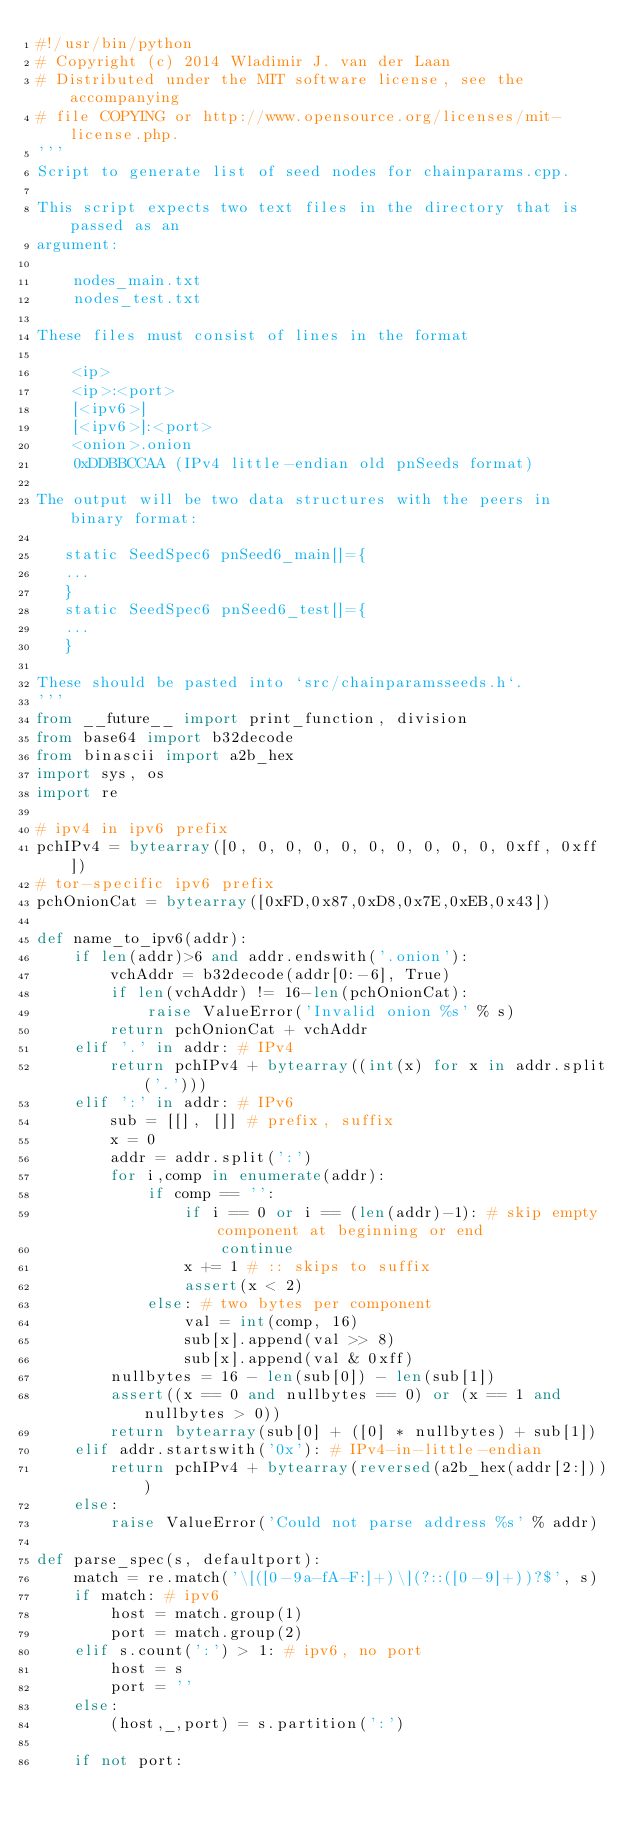Convert code to text. <code><loc_0><loc_0><loc_500><loc_500><_Python_>#!/usr/bin/python
# Copyright (c) 2014 Wladimir J. van der Laan
# Distributed under the MIT software license, see the accompanying
# file COPYING or http://www.opensource.org/licenses/mit-license.php.
'''
Script to generate list of seed nodes for chainparams.cpp.

This script expects two text files in the directory that is passed as an
argument:

    nodes_main.txt
    nodes_test.txt

These files must consist of lines in the format 

    <ip>
    <ip>:<port>
    [<ipv6>]
    [<ipv6>]:<port>
    <onion>.onion
    0xDDBBCCAA (IPv4 little-endian old pnSeeds format)

The output will be two data structures with the peers in binary format:

   static SeedSpec6 pnSeed6_main[]={
   ...
   }
   static SeedSpec6 pnSeed6_test[]={
   ...
   }

These should be pasted into `src/chainparamsseeds.h`.
'''
from __future__ import print_function, division
from base64 import b32decode
from binascii import a2b_hex
import sys, os
import re

# ipv4 in ipv6 prefix
pchIPv4 = bytearray([0, 0, 0, 0, 0, 0, 0, 0, 0, 0, 0xff, 0xff])
# tor-specific ipv6 prefix
pchOnionCat = bytearray([0xFD,0x87,0xD8,0x7E,0xEB,0x43])

def name_to_ipv6(addr):
    if len(addr)>6 and addr.endswith('.onion'):
        vchAddr = b32decode(addr[0:-6], True)
        if len(vchAddr) != 16-len(pchOnionCat):
            raise ValueError('Invalid onion %s' % s)
        return pchOnionCat + vchAddr
    elif '.' in addr: # IPv4
        return pchIPv4 + bytearray((int(x) for x in addr.split('.')))
    elif ':' in addr: # IPv6
        sub = [[], []] # prefix, suffix
        x = 0
        addr = addr.split(':')
        for i,comp in enumerate(addr):
            if comp == '':
                if i == 0 or i == (len(addr)-1): # skip empty component at beginning or end
                    continue
                x += 1 # :: skips to suffix
                assert(x < 2)
            else: # two bytes per component
                val = int(comp, 16)
                sub[x].append(val >> 8)
                sub[x].append(val & 0xff)
        nullbytes = 16 - len(sub[0]) - len(sub[1])
        assert((x == 0 and nullbytes == 0) or (x == 1 and nullbytes > 0))
        return bytearray(sub[0] + ([0] * nullbytes) + sub[1])
    elif addr.startswith('0x'): # IPv4-in-little-endian
        return pchIPv4 + bytearray(reversed(a2b_hex(addr[2:])))
    else:
        raise ValueError('Could not parse address %s' % addr)

def parse_spec(s, defaultport):
    match = re.match('\[([0-9a-fA-F:]+)\](?::([0-9]+))?$', s)
    if match: # ipv6
        host = match.group(1)
        port = match.group(2)
    elif s.count(':') > 1: # ipv6, no port
        host = s
        port = ''
    else:
        (host,_,port) = s.partition(':')

    if not port:</code> 